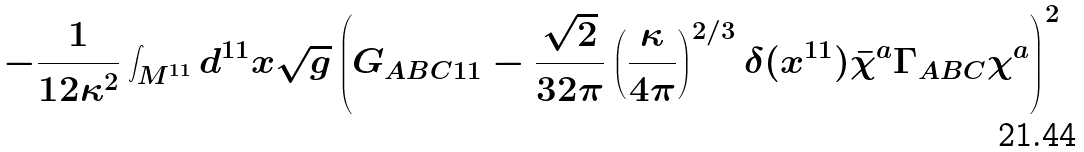Convert formula to latex. <formula><loc_0><loc_0><loc_500><loc_500>- \frac { 1 } { 1 2 \kappa ^ { 2 } } \int _ { M ^ { 1 1 } } d ^ { 1 1 } x \sqrt { g } \left ( G _ { A B C 1 1 } - \frac { \sqrt { 2 } } { 3 2 \pi } \left ( \frac { \kappa } { 4 \pi } \right ) ^ { 2 / 3 } \delta ( x ^ { 1 1 } ) \bar { \chi } ^ { a } \Gamma _ { A B C } \chi ^ { a } \right ) ^ { 2 }</formula> 